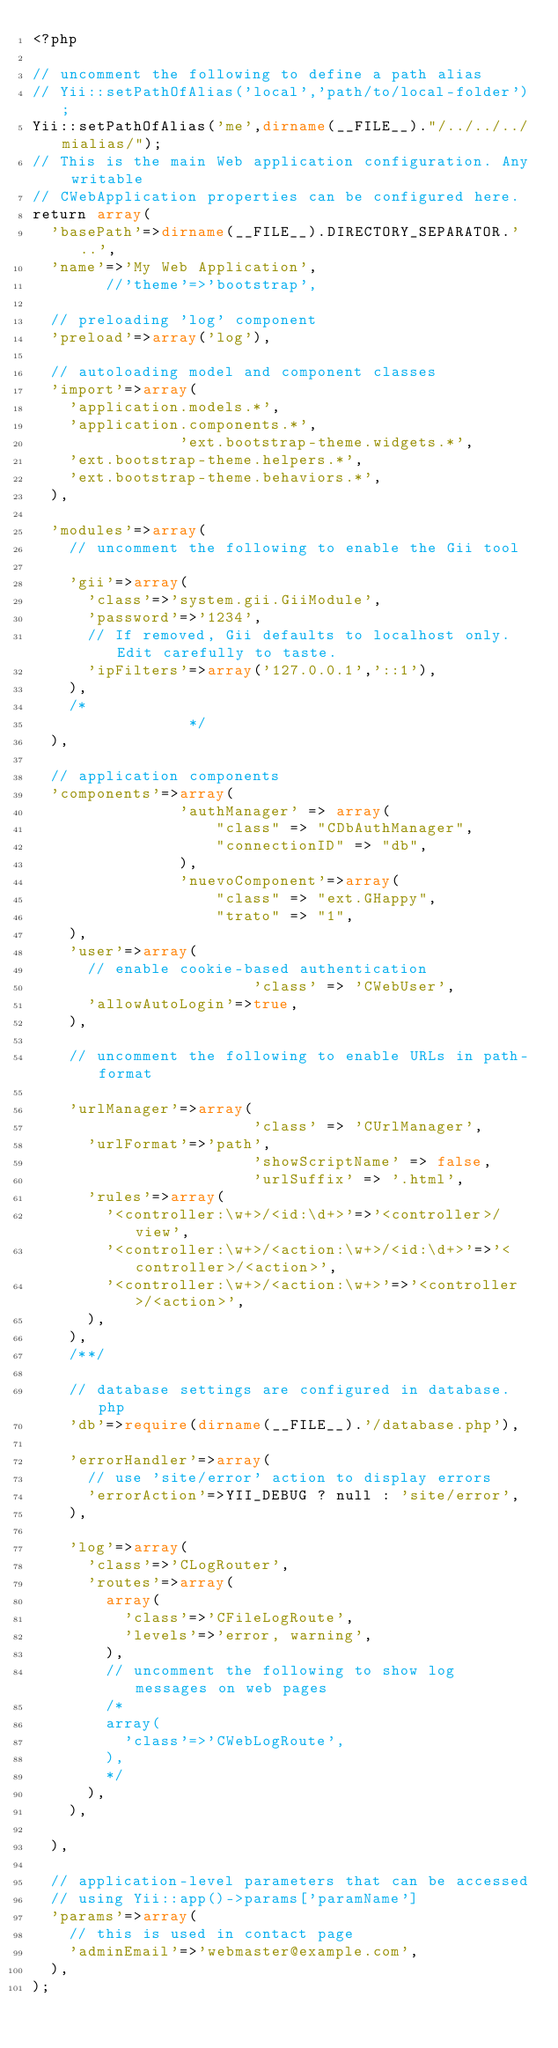Convert code to text. <code><loc_0><loc_0><loc_500><loc_500><_PHP_><?php

// uncomment the following to define a path alias
// Yii::setPathOfAlias('local','path/to/local-folder');
Yii::setPathOfAlias('me',dirname(__FILE__)."/../../../mialias/"); 
// This is the main Web application configuration. Any writable
// CWebApplication properties can be configured here.
return array(
	'basePath'=>dirname(__FILE__).DIRECTORY_SEPARATOR.'..',
	'name'=>'My Web Application',
        //'theme'=>'bootstrap',

	// preloading 'log' component
	'preload'=>array('log'),

	// autoloading model and component classes
	'import'=>array(
		'application.models.*',
		'application.components.*',
                'ext.bootstrap-theme.widgets.*',
		'ext.bootstrap-theme.helpers.*',
		'ext.bootstrap-theme.behaviors.*',
	),

	'modules'=>array(
		// uncomment the following to enable the Gii tool
		
		'gii'=>array(
			'class'=>'system.gii.GiiModule',
			'password'=>'1234',
			// If removed, Gii defaults to localhost only. Edit carefully to taste.
			'ipFilters'=>array('127.0.0.1','::1'),
		),
		/*
                 */
	),

	// application components
	'components'=>array(
                'authManager' => array(
                    "class" => "CDbAuthManager",
                    "connectionID" => "db",
                ),
                'nuevoComponent'=>array(
                    "class" => "ext.GHappy",
                    "trato" => "1",                   
		),            
		'user'=>array(
			// enable cookie-based authentication
                        'class' => 'CWebUser',
			'allowAutoLogin'=>true,
		),

		// uncomment the following to enable URLs in path-format
		
		'urlManager'=>array(
                        'class' => 'CUrlManager',
			'urlFormat'=>'path',
                        'showScriptName' => false,
                        'urlSuffix' => '.html',
			'rules'=>array(
				'<controller:\w+>/<id:\d+>'=>'<controller>/view',
				'<controller:\w+>/<action:\w+>/<id:\d+>'=>'<controller>/<action>',
				'<controller:\w+>/<action:\w+>'=>'<controller>/<action>',
			),
		),
		/**/

		// database settings are configured in database.php
		'db'=>require(dirname(__FILE__).'/database.php'),

		'errorHandler'=>array(
			// use 'site/error' action to display errors
			'errorAction'=>YII_DEBUG ? null : 'site/error',
		),

		'log'=>array(
			'class'=>'CLogRouter',
			'routes'=>array(
				array(
					'class'=>'CFileLogRoute',
					'levels'=>'error, warning',
				),
				// uncomment the following to show log messages on web pages
				/*
				array(
					'class'=>'CWebLogRoute',
				),
				*/
			),
		),

	),

	// application-level parameters that can be accessed
	// using Yii::app()->params['paramName']
	'params'=>array(
		// this is used in contact page
		'adminEmail'=>'webmaster@example.com',
	),
);
</code> 